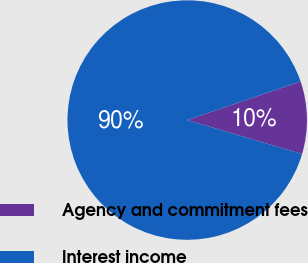Convert chart to OTSL. <chart><loc_0><loc_0><loc_500><loc_500><pie_chart><fcel>Agency and commitment fees<fcel>Interest income<nl><fcel>9.8%<fcel>90.2%<nl></chart> 